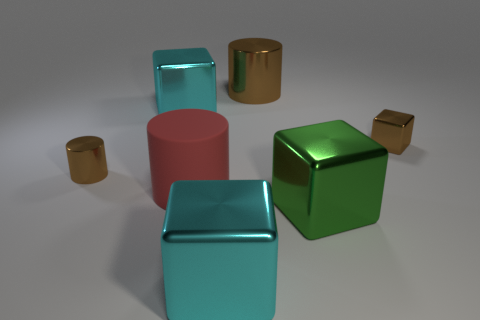What material is the large thing that is the same color as the tiny shiny block?
Give a very brief answer. Metal. The small brown thing that is to the left of the brown thing behind the metal thing to the right of the large green cube is made of what material?
Keep it short and to the point. Metal. What is the size of the other metallic cylinder that is the same color as the tiny metal cylinder?
Your answer should be compact. Large. What is the big red cylinder made of?
Keep it short and to the point. Rubber. Is the material of the large brown thing the same as the cyan block to the left of the large red rubber thing?
Provide a succinct answer. Yes. There is a tiny shiny object in front of the tiny shiny thing that is behind the small cylinder; what color is it?
Offer a very short reply. Brown. What is the size of the block that is on the right side of the large matte thing and behind the large matte cylinder?
Provide a short and direct response. Small. How many other objects are the same shape as the big green metal object?
Your answer should be compact. 3. Does the big red object have the same shape as the brown object that is left of the big brown cylinder?
Your response must be concise. Yes. There is a big red object; what number of cyan metallic blocks are left of it?
Your answer should be very brief. 1. 